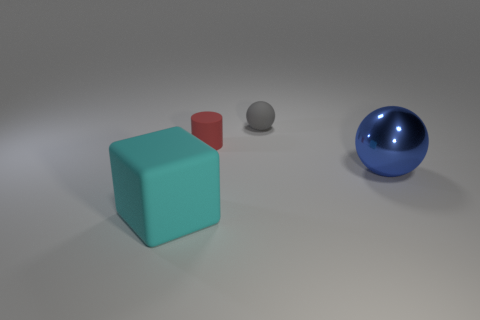What shape is the object in front of the blue sphere that is right of the tiny gray sphere?
Keep it short and to the point. Cube. Are there more small gray spheres that are left of the blue metallic thing than shiny cylinders?
Your answer should be compact. Yes. Does the tiny rubber thing behind the small red matte object have the same shape as the large blue thing?
Offer a very short reply. Yes. Is there a tiny matte thing of the same shape as the large metal object?
Provide a short and direct response. Yes. What number of objects are either balls behind the big metallic sphere or blue shiny cylinders?
Give a very brief answer. 1. Is the number of red matte objects greater than the number of small yellow rubber balls?
Keep it short and to the point. Yes. Are there any gray shiny spheres that have the same size as the blue metal object?
Keep it short and to the point. No. How many objects are tiny objects that are behind the red rubber thing or rubber objects that are left of the gray matte thing?
Your answer should be compact. 3. What color is the big thing in front of the big thing behind the big cyan matte object?
Your answer should be compact. Cyan. What color is the tiny object that is made of the same material as the small gray sphere?
Your response must be concise. Red. 